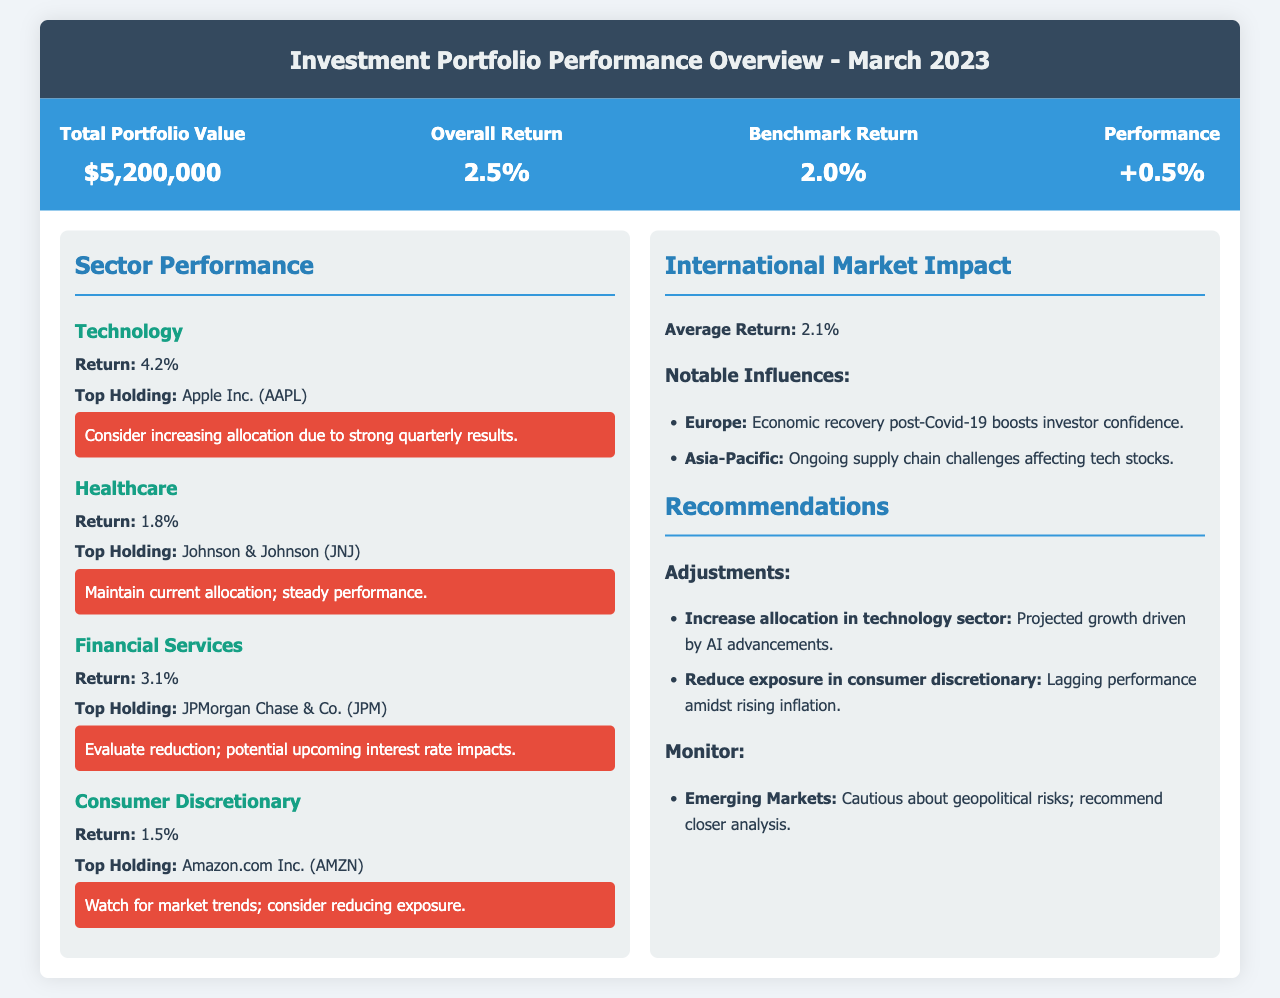What is the total portfolio value? The total portfolio value is listed in the summary section of the document as $5,200,000.
Answer: $5,200,000 What is the overall return for March 2023? The overall return is specified in the summary section of the document, which indicates an overall return of 2.5%.
Answer: 2.5% Which sector had the highest return? To determine which sector had the highest return, we compare the returns listed for each sector; Technology has the highest return at 4.2%.
Answer: Technology What is the top holding in the Financial Services sector? The document states that the top holding in the Financial Services sector is JPMorgan Chase & Co. (JPM).
Answer: JPMorgan Chase & Co. (JPM) What is the average return for the International Market? The average return for the International Market is specified as 2.1% in the relevant section.
Answer: 2.1% What recommendation is given for increasing allocation? The document recommends increasing allocation in the technology sector due to projected growth driven by AI advancements.
Answer: technology sector What should be monitored according to the document? The document advises monitoring Emerging Markets due to geopolitical risks.
Answer: Emerging Markets What was the performance relative to the benchmark? The performance is derived by comparing the overall return to the benchmark return, which results in a performance of +0.5%.
Answer: +0.5% Which company is mentioned as the top holding in the Healthcare sector? The document marks Johnson & Johnson (JNJ) as the top holding in the Healthcare sector.
Answer: Johnson & Johnson (JNJ) 